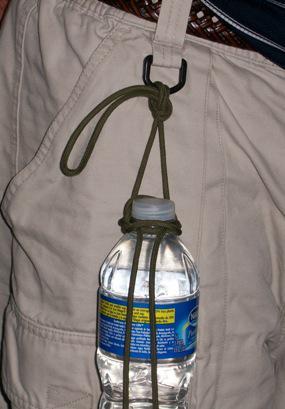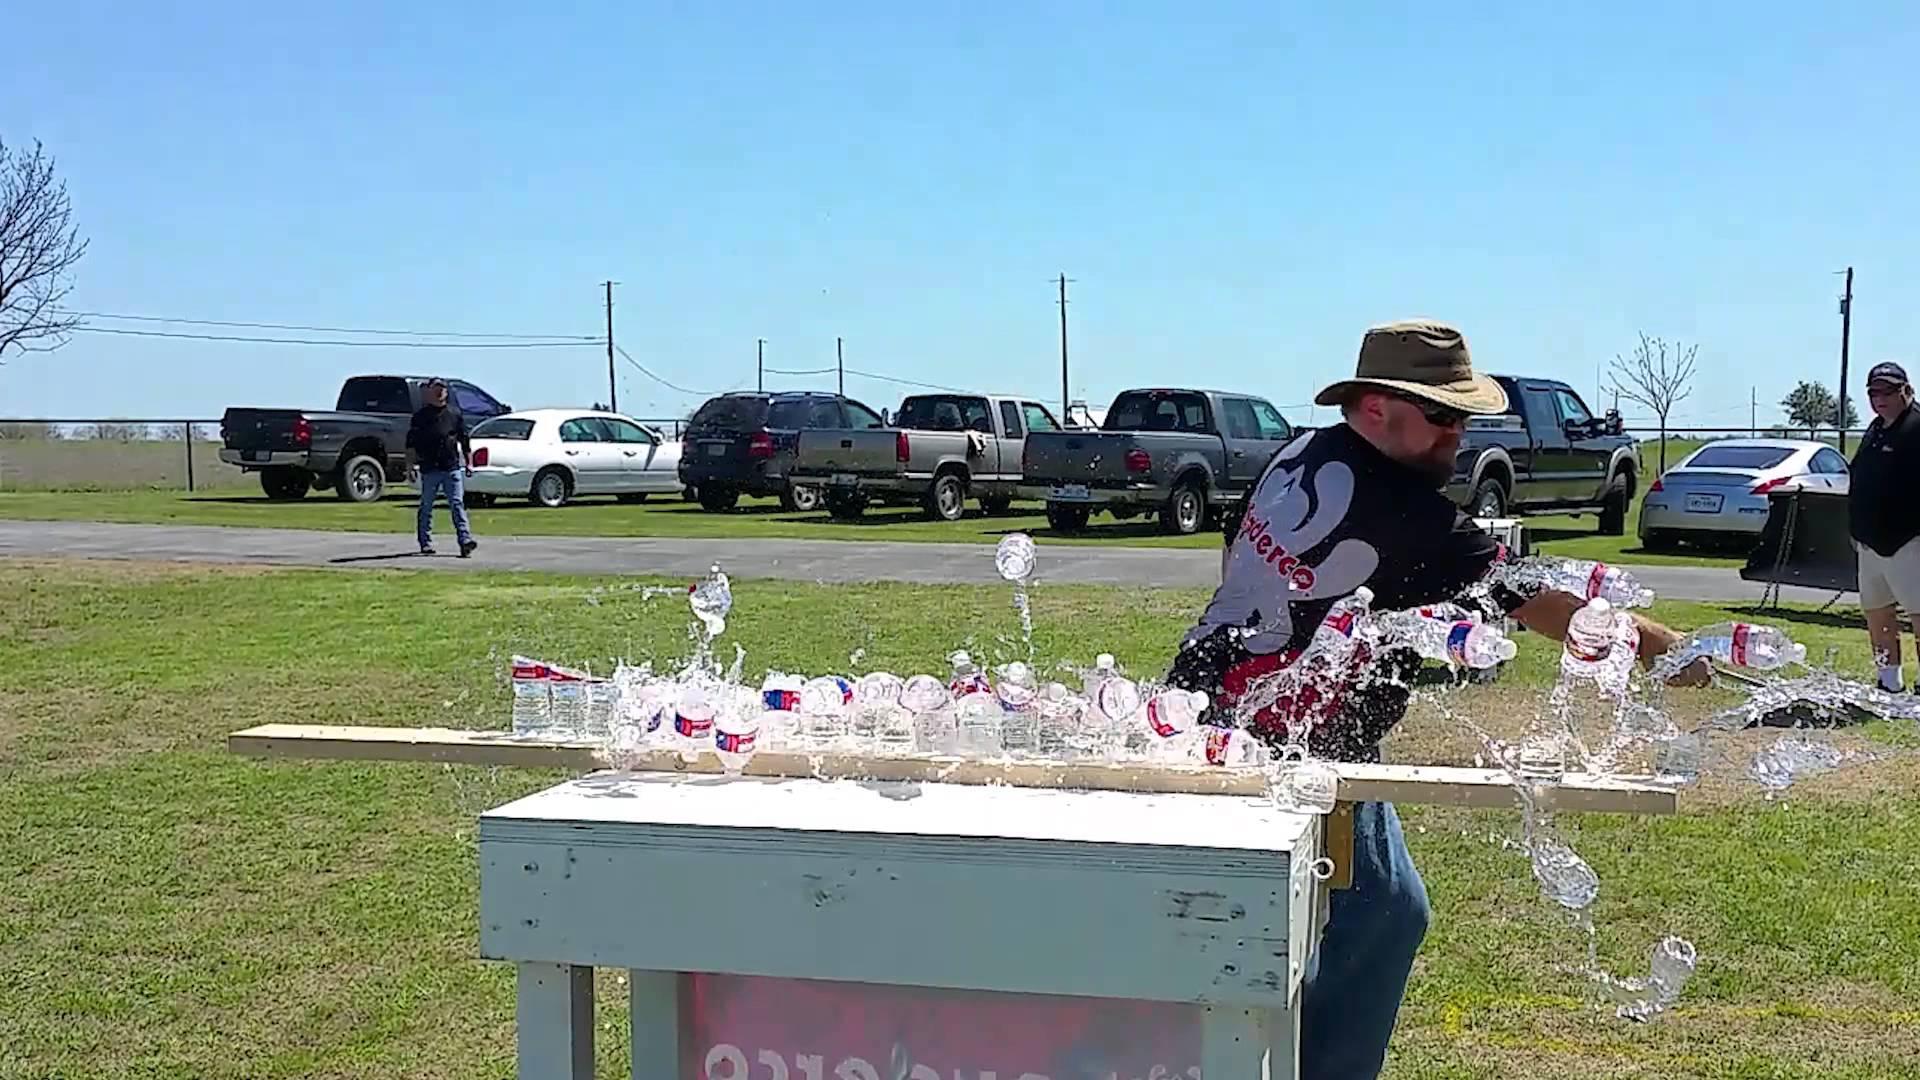The first image is the image on the left, the second image is the image on the right. For the images shown, is this caption "There is at least one disposable water bottle with a white cap." true? Answer yes or no. Yes. The first image is the image on the left, the second image is the image on the right. Analyze the images presented: Is the assertion "singular water bottles are surrounded by rop" valid? Answer yes or no. Yes. 